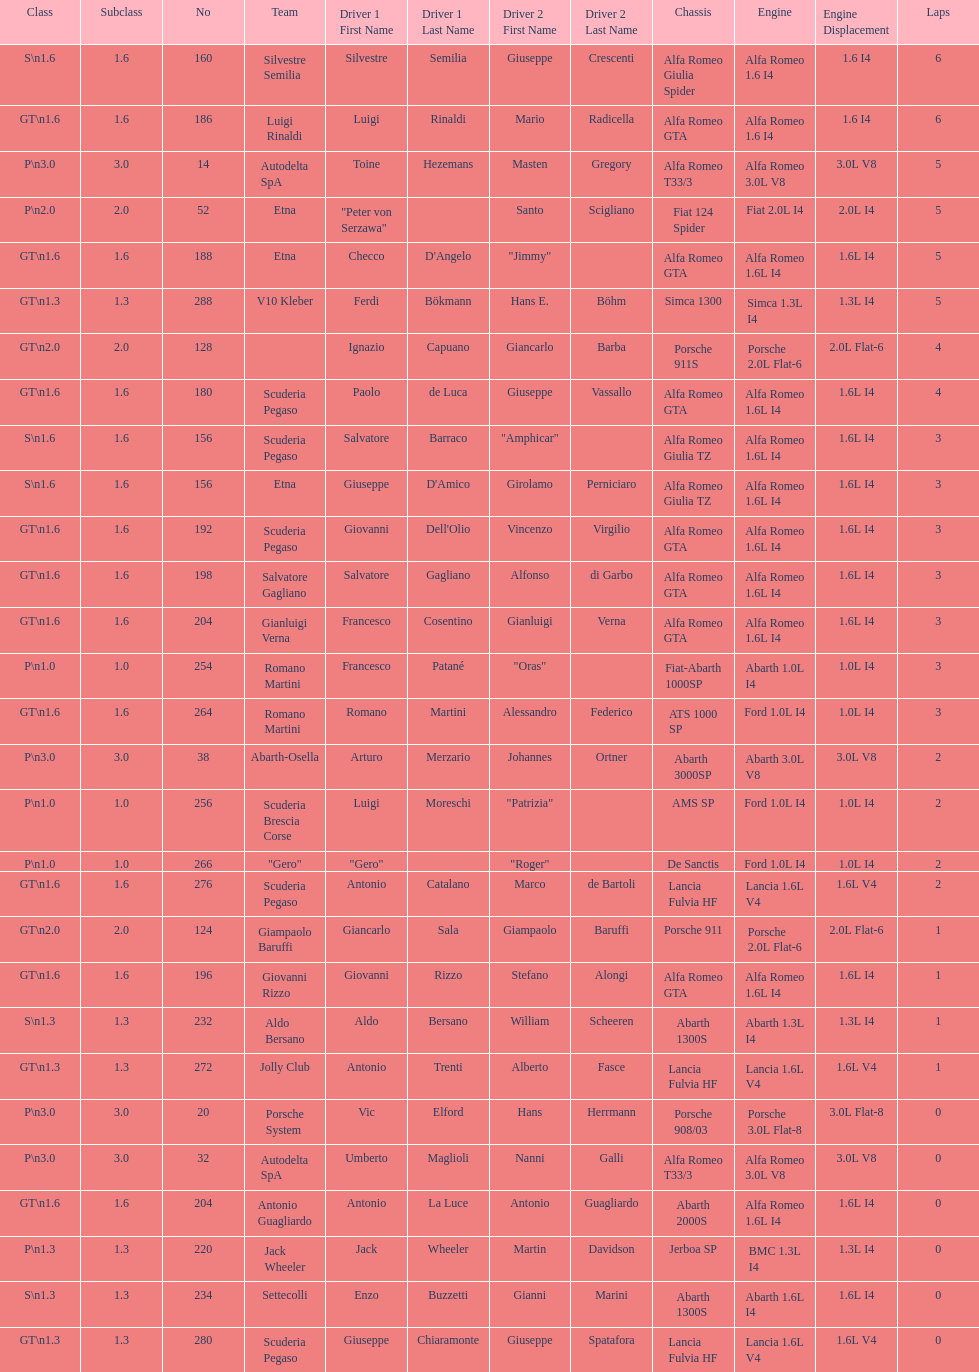His nickname is "jimmy," but what is his full name? Checco D'Angelo. 